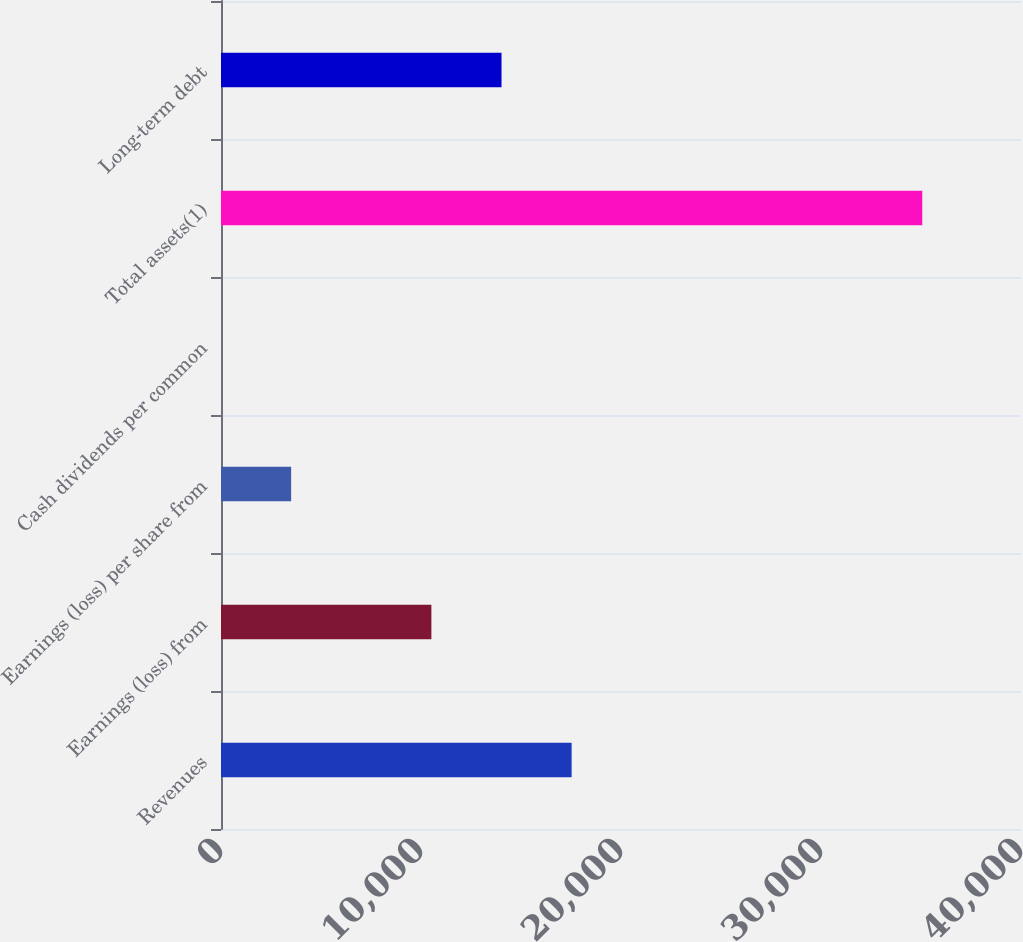<chart> <loc_0><loc_0><loc_500><loc_500><bar_chart><fcel>Revenues<fcel>Earnings (loss) from<fcel>Earnings (loss) per share from<fcel>Cash dividends per common<fcel>Total assets(1)<fcel>Long-term debt<nl><fcel>17531.7<fcel>10519.2<fcel>3506.71<fcel>0.45<fcel>35063<fcel>14025.5<nl></chart> 